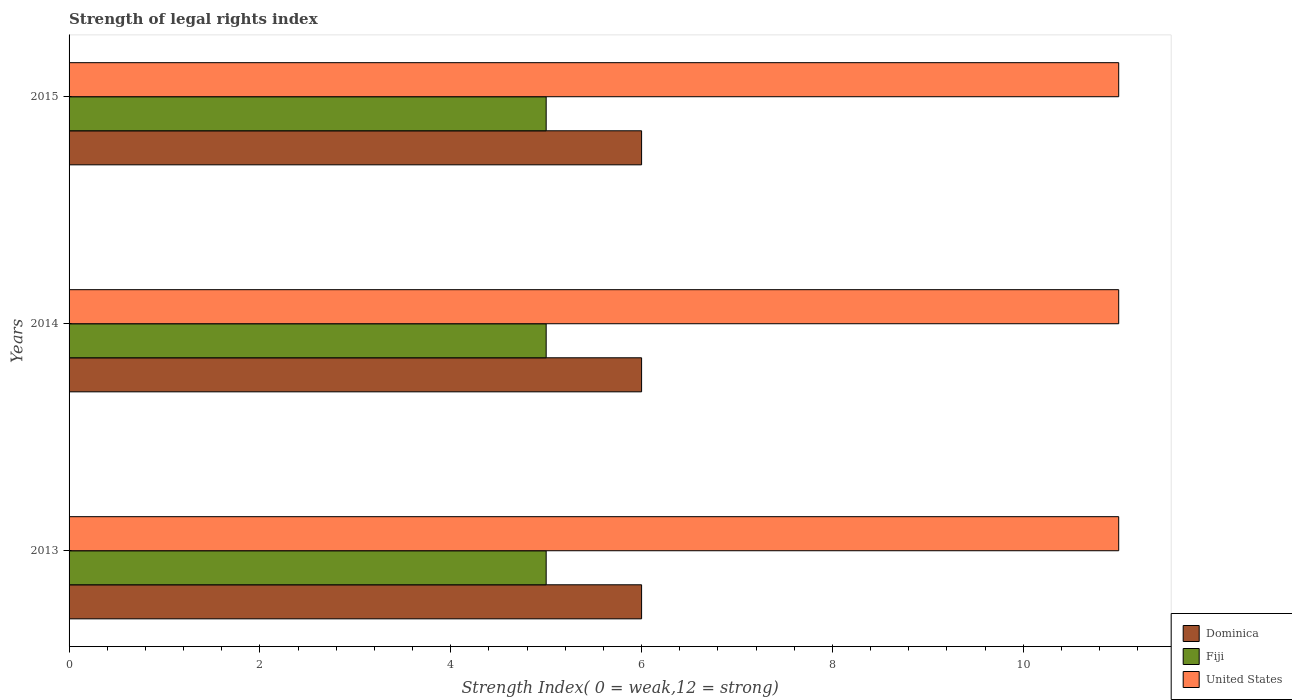How many different coloured bars are there?
Your answer should be very brief. 3. Are the number of bars on each tick of the Y-axis equal?
Provide a succinct answer. Yes. How many bars are there on the 1st tick from the top?
Give a very brief answer. 3. What is the label of the 1st group of bars from the top?
Make the answer very short. 2015. What is the strength index in Fiji in 2015?
Provide a short and direct response. 5. Across all years, what is the maximum strength index in United States?
Give a very brief answer. 11. Across all years, what is the minimum strength index in United States?
Give a very brief answer. 11. In which year was the strength index in Fiji minimum?
Keep it short and to the point. 2013. What is the total strength index in Dominica in the graph?
Give a very brief answer. 18. What is the difference between the strength index in United States in 2013 and that in 2015?
Your answer should be very brief. 0. What is the difference between the strength index in Fiji in 2014 and the strength index in Dominica in 2013?
Offer a very short reply. -1. In the year 2013, what is the difference between the strength index in Fiji and strength index in Dominica?
Your answer should be compact. -1. In how many years, is the strength index in Dominica greater than 4 ?
Your answer should be compact. 3. What is the ratio of the strength index in United States in 2013 to that in 2014?
Ensure brevity in your answer.  1. Is the strength index in Fiji in 2013 less than that in 2014?
Provide a succinct answer. No. What is the difference between the highest and the lowest strength index in United States?
Give a very brief answer. 0. In how many years, is the strength index in Fiji greater than the average strength index in Fiji taken over all years?
Offer a very short reply. 0. What does the 3rd bar from the top in 2014 represents?
Provide a short and direct response. Dominica. What does the 2nd bar from the bottom in 2014 represents?
Provide a short and direct response. Fiji. Are all the bars in the graph horizontal?
Your response must be concise. Yes. What is the difference between two consecutive major ticks on the X-axis?
Provide a short and direct response. 2. Are the values on the major ticks of X-axis written in scientific E-notation?
Offer a terse response. No. Where does the legend appear in the graph?
Offer a terse response. Bottom right. How are the legend labels stacked?
Ensure brevity in your answer.  Vertical. What is the title of the graph?
Provide a short and direct response. Strength of legal rights index. What is the label or title of the X-axis?
Make the answer very short. Strength Index( 0 = weak,12 = strong). What is the Strength Index( 0 = weak,12 = strong) in United States in 2013?
Offer a very short reply. 11. What is the Strength Index( 0 = weak,12 = strong) in Fiji in 2014?
Your answer should be compact. 5. What is the Strength Index( 0 = weak,12 = strong) of United States in 2014?
Provide a short and direct response. 11. What is the Strength Index( 0 = weak,12 = strong) in Fiji in 2015?
Make the answer very short. 5. Across all years, what is the maximum Strength Index( 0 = weak,12 = strong) of Dominica?
Give a very brief answer. 6. Across all years, what is the maximum Strength Index( 0 = weak,12 = strong) of Fiji?
Ensure brevity in your answer.  5. Across all years, what is the minimum Strength Index( 0 = weak,12 = strong) in Dominica?
Your answer should be very brief. 6. Across all years, what is the minimum Strength Index( 0 = weak,12 = strong) in Fiji?
Your response must be concise. 5. Across all years, what is the minimum Strength Index( 0 = weak,12 = strong) in United States?
Offer a terse response. 11. What is the total Strength Index( 0 = weak,12 = strong) in Fiji in the graph?
Make the answer very short. 15. What is the difference between the Strength Index( 0 = weak,12 = strong) in Fiji in 2013 and that in 2014?
Provide a succinct answer. 0. What is the difference between the Strength Index( 0 = weak,12 = strong) in Dominica in 2013 and that in 2015?
Ensure brevity in your answer.  0. What is the difference between the Strength Index( 0 = weak,12 = strong) of Fiji in 2014 and that in 2015?
Ensure brevity in your answer.  0. What is the difference between the Strength Index( 0 = weak,12 = strong) of United States in 2014 and that in 2015?
Offer a terse response. 0. What is the difference between the Strength Index( 0 = weak,12 = strong) in Fiji in 2013 and the Strength Index( 0 = weak,12 = strong) in United States in 2014?
Provide a short and direct response. -6. What is the difference between the Strength Index( 0 = weak,12 = strong) of Dominica in 2013 and the Strength Index( 0 = weak,12 = strong) of Fiji in 2015?
Keep it short and to the point. 1. What is the difference between the Strength Index( 0 = weak,12 = strong) in Dominica in 2013 and the Strength Index( 0 = weak,12 = strong) in United States in 2015?
Provide a succinct answer. -5. What is the difference between the Strength Index( 0 = weak,12 = strong) of Fiji in 2013 and the Strength Index( 0 = weak,12 = strong) of United States in 2015?
Provide a succinct answer. -6. What is the difference between the Strength Index( 0 = weak,12 = strong) of Dominica in 2014 and the Strength Index( 0 = weak,12 = strong) of United States in 2015?
Offer a terse response. -5. What is the average Strength Index( 0 = weak,12 = strong) in Dominica per year?
Make the answer very short. 6. What is the average Strength Index( 0 = weak,12 = strong) in Fiji per year?
Your response must be concise. 5. What is the average Strength Index( 0 = weak,12 = strong) in United States per year?
Your answer should be very brief. 11. In the year 2013, what is the difference between the Strength Index( 0 = weak,12 = strong) in Dominica and Strength Index( 0 = weak,12 = strong) in Fiji?
Give a very brief answer. 1. In the year 2013, what is the difference between the Strength Index( 0 = weak,12 = strong) of Dominica and Strength Index( 0 = weak,12 = strong) of United States?
Your answer should be compact. -5. In the year 2013, what is the difference between the Strength Index( 0 = weak,12 = strong) of Fiji and Strength Index( 0 = weak,12 = strong) of United States?
Keep it short and to the point. -6. In the year 2014, what is the difference between the Strength Index( 0 = weak,12 = strong) of Fiji and Strength Index( 0 = weak,12 = strong) of United States?
Make the answer very short. -6. In the year 2015, what is the difference between the Strength Index( 0 = weak,12 = strong) in Dominica and Strength Index( 0 = weak,12 = strong) in Fiji?
Give a very brief answer. 1. What is the ratio of the Strength Index( 0 = weak,12 = strong) in Dominica in 2013 to that in 2014?
Give a very brief answer. 1. What is the ratio of the Strength Index( 0 = weak,12 = strong) of Fiji in 2013 to that in 2014?
Offer a terse response. 1. What is the ratio of the Strength Index( 0 = weak,12 = strong) in United States in 2013 to that in 2014?
Offer a terse response. 1. What is the ratio of the Strength Index( 0 = weak,12 = strong) of Dominica in 2013 to that in 2015?
Give a very brief answer. 1. What is the ratio of the Strength Index( 0 = weak,12 = strong) of United States in 2013 to that in 2015?
Provide a succinct answer. 1. What is the ratio of the Strength Index( 0 = weak,12 = strong) in Dominica in 2014 to that in 2015?
Offer a terse response. 1. What is the ratio of the Strength Index( 0 = weak,12 = strong) of Fiji in 2014 to that in 2015?
Offer a very short reply. 1. What is the difference between the highest and the second highest Strength Index( 0 = weak,12 = strong) of Dominica?
Ensure brevity in your answer.  0. What is the difference between the highest and the lowest Strength Index( 0 = weak,12 = strong) in United States?
Give a very brief answer. 0. 